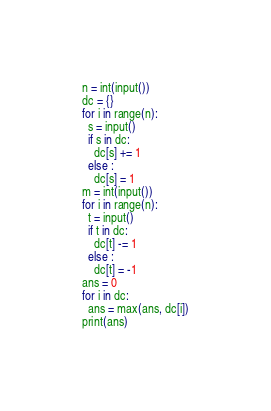<code> <loc_0><loc_0><loc_500><loc_500><_Python_>n = int(input())
dc = {}
for i in range(n):
  s = input()
  if s in dc:
    dc[s] += 1
  else :
    dc[s] = 1
m = int(input())
for i in range(n):
  t = input()
  if t in dc:
    dc[t] -= 1
  else :
    dc[t] = -1
ans = 0
for i in dc:
  ans = max(ans, dc[i])
print(ans)</code> 